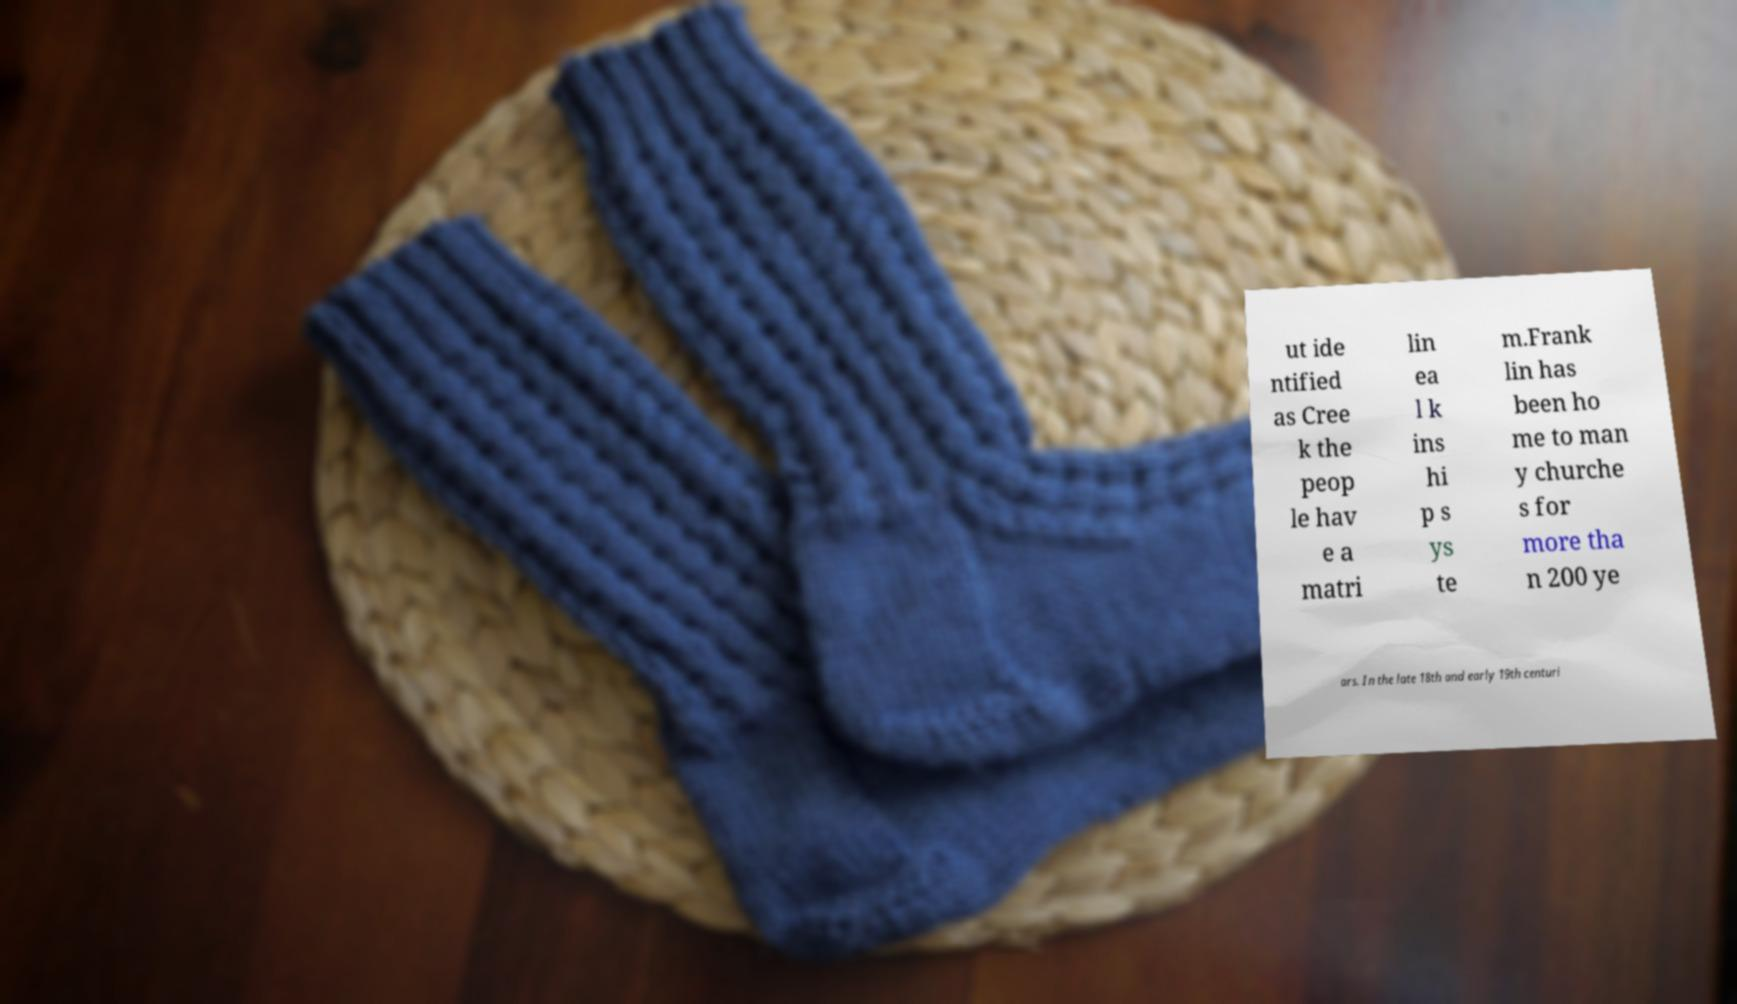Please identify and transcribe the text found in this image. ut ide ntified as Cree k the peop le hav e a matri lin ea l k ins hi p s ys te m.Frank lin has been ho me to man y churche s for more tha n 200 ye ars. In the late 18th and early 19th centuri 